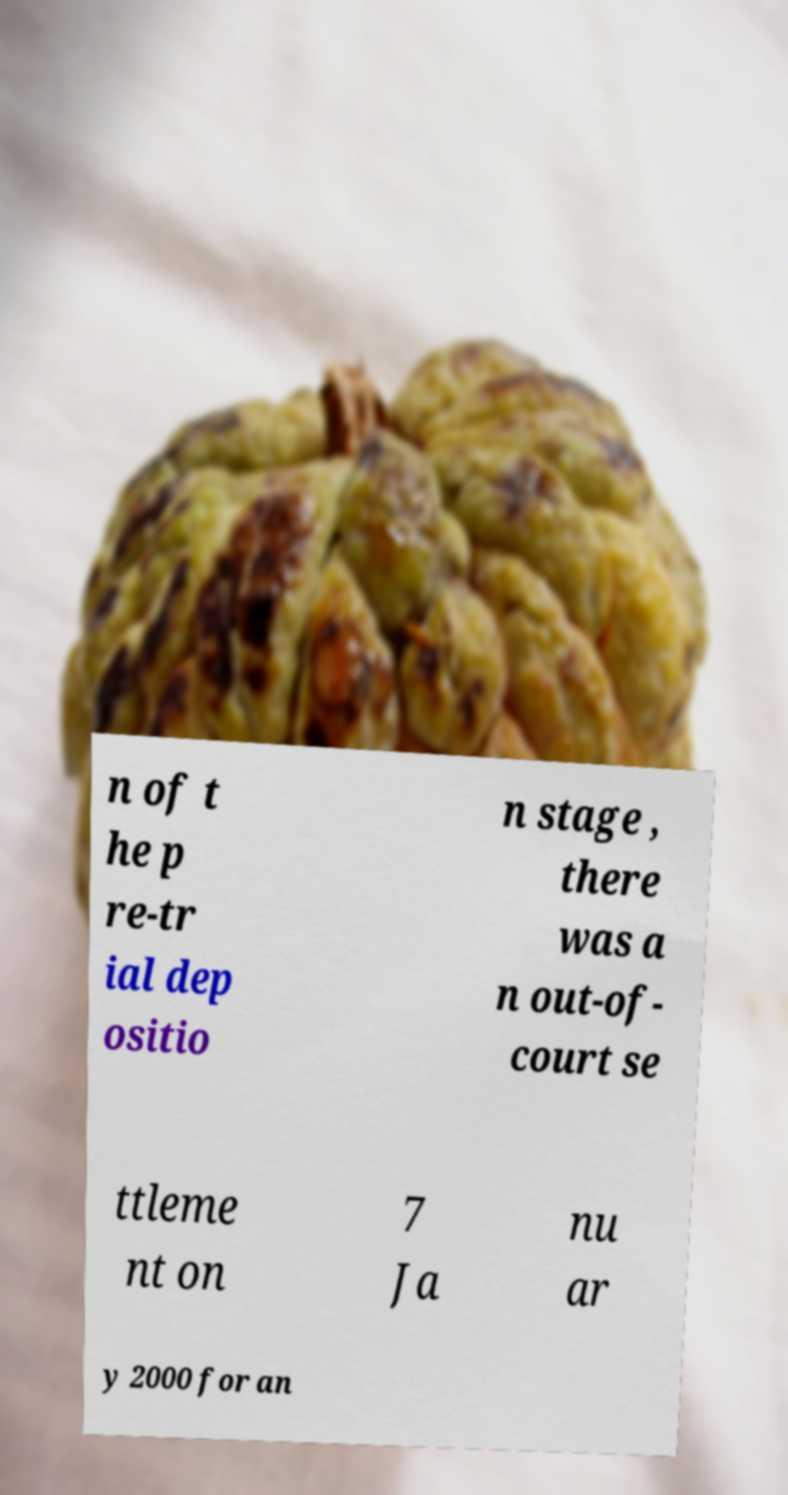Can you read and provide the text displayed in the image?This photo seems to have some interesting text. Can you extract and type it out for me? n of t he p re-tr ial dep ositio n stage , there was a n out-of- court se ttleme nt on 7 Ja nu ar y 2000 for an 